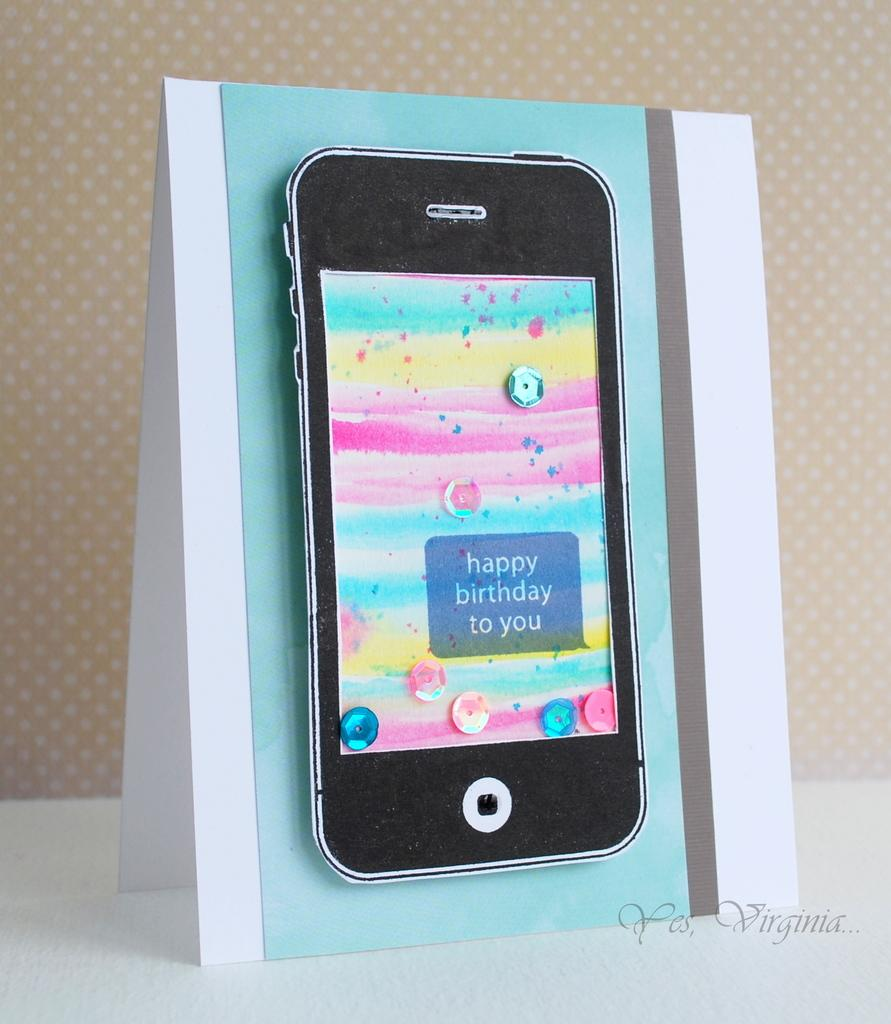<image>
Write a terse but informative summary of the picture. A happy birthday to you card has a picture of a phone on the front 